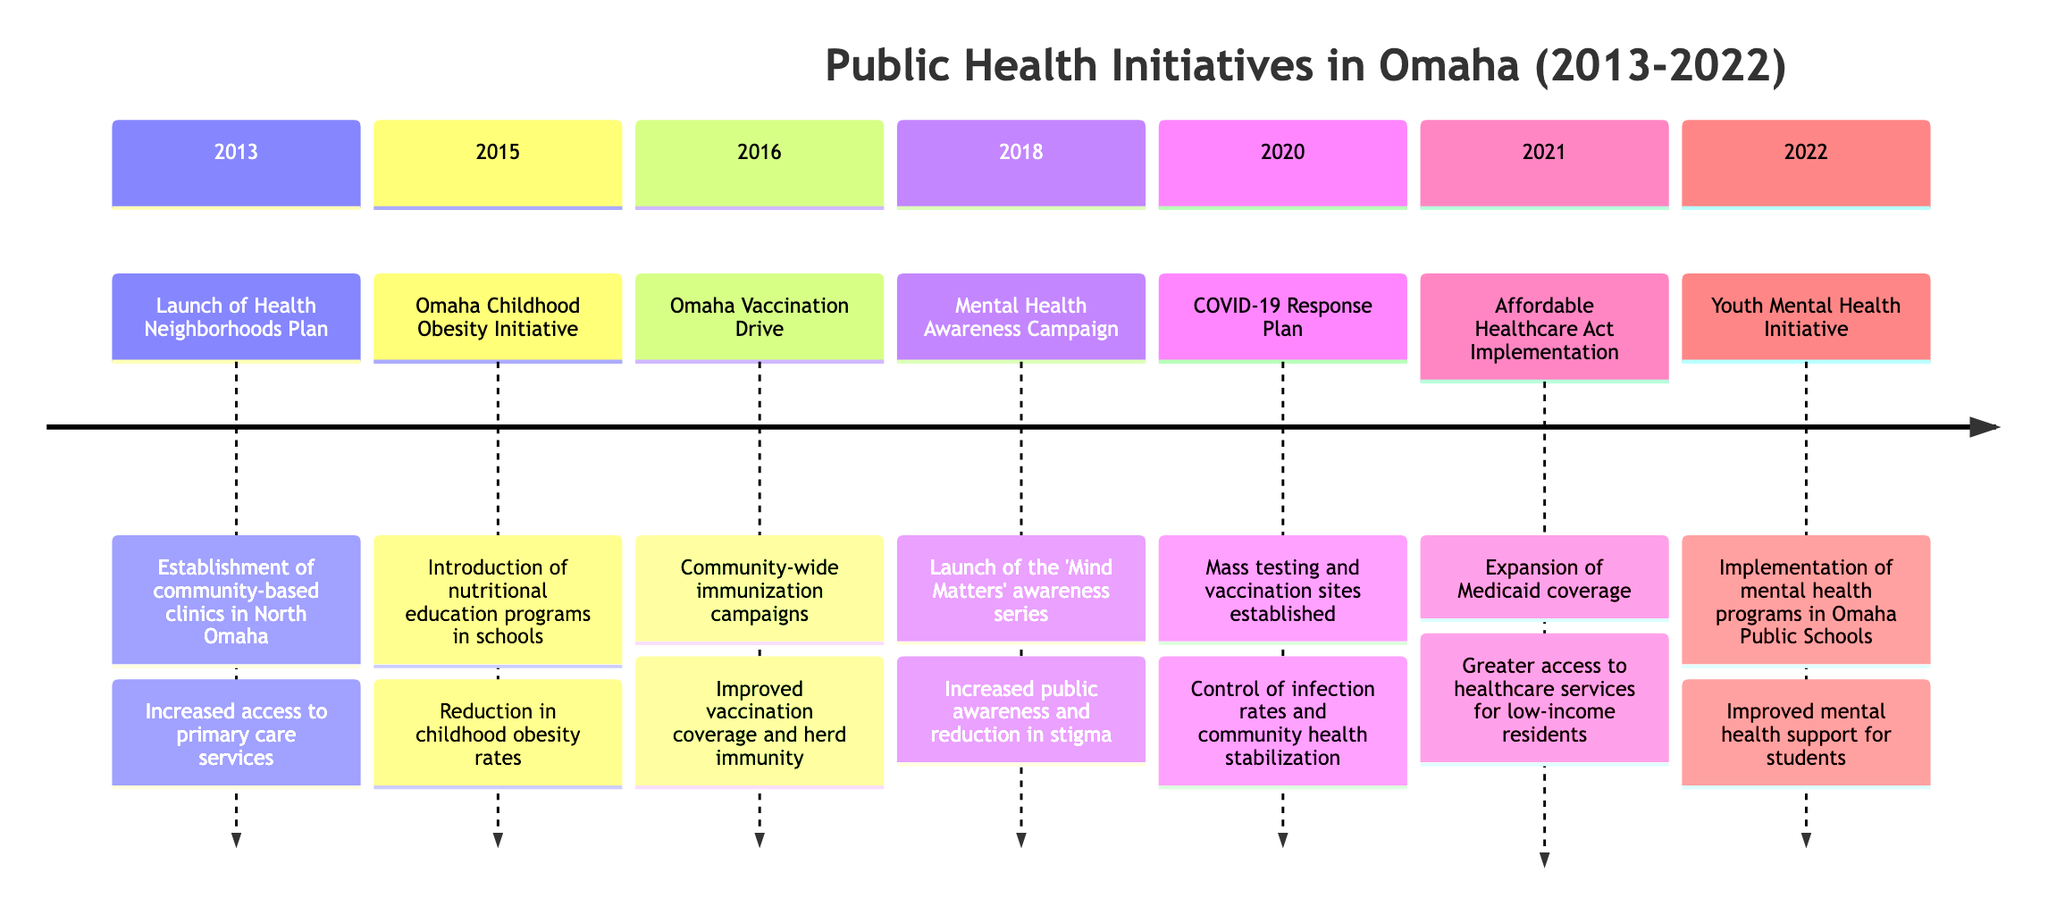What was launched in 2013? The diagram states that the 'Health Neighborhoods Plan' was launched in 2013, which was aimed at establishing community-based clinics in North Omaha.
Answer: Health Neighborhoods Plan What initiative focused on childhood obesity? According to the timeline, the 'Omaha Childhood Obesity Initiative' was specifically introduced in 2015 to address childhood obesity rates through nutritional education programs in schools.
Answer: Omaha Childhood Obesity Initiative How many public health initiatives were launched in 2020? By examining the timeline, it shows that there was one major public health initiative launched in 2020, which was the 'COVID-19 Response Plan.'
Answer: 1 What was the primary impact of the Omaha Vaccination Drive? The diagram indicates that the 'Omaha Vaccination Drive' led to improved vaccination coverage and herd immunity, showcasing its positive impact on public health.
Answer: Improved vaccination coverage and herd immunity Which initiative was introduced in 2021? The timeline specifies that the 'Affordable Healthcare Act Implementation' was the initiative introduced in 2021, aimed at expanding Medicaid coverage for residents.
Answer: Affordable Healthcare Act Implementation How did the Mental Health Awareness Campaign impact public perception? The 'Mental Health Awareness Campaign' that launched in 2018 resulted in increased public awareness and a reduction in stigma around mental health issues, highlighting its significant impact.
Answer: Increased public awareness and reduction in stigma What year did the Youth Mental Health Initiative start? The diagram clearly states that the 'Youth Mental Health Initiative' was implemented in 2022, providing mental health programs in Omaha Public Schools.
Answer: 2022 How many sections are represented in the timeline? Counting the sections in the timeline reveals that there are a total of seven sections representing various initiatives across different years from 2013 to 2022.
Answer: 7 What initiative aimed at improving mental health support in schools? The timeline indicates that the 'Youth Mental Health Initiative' was aimed at improving mental health support specifically within Omaha Public Schools.
Answer: Youth Mental Health Initiative 